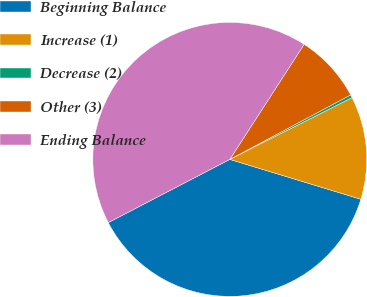<chart> <loc_0><loc_0><loc_500><loc_500><pie_chart><fcel>Beginning Balance<fcel>Increase (1)<fcel>Decrease (2)<fcel>Other (3)<fcel>Ending Balance<nl><fcel>37.67%<fcel>12.15%<fcel>0.35%<fcel>8.07%<fcel>41.76%<nl></chart> 